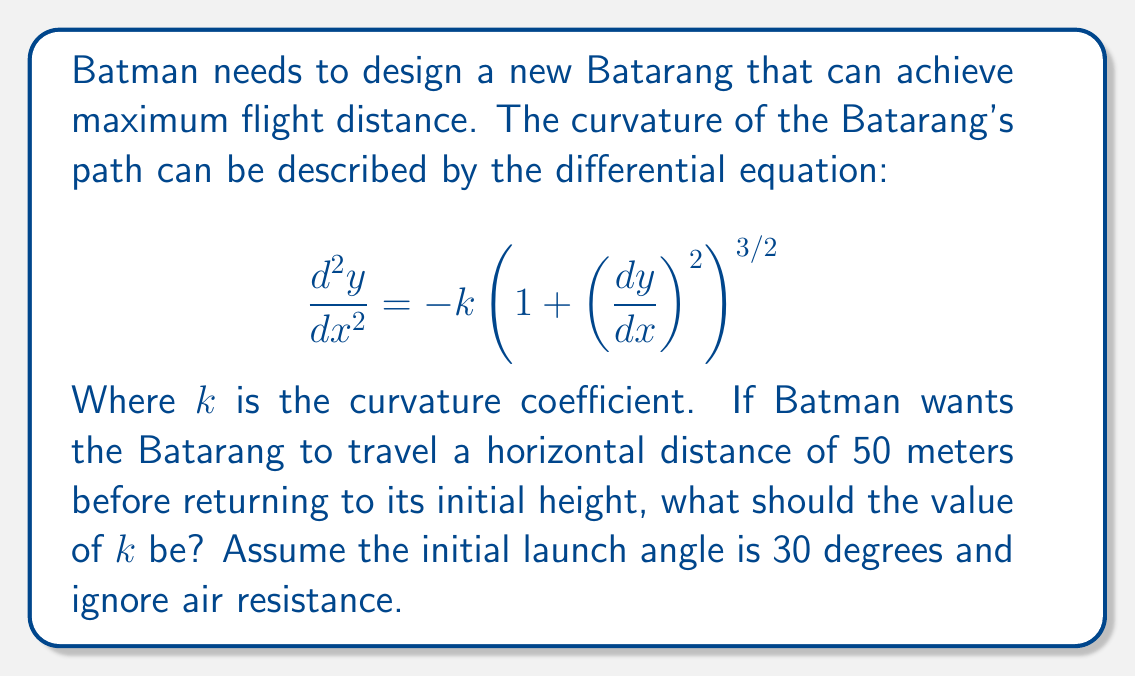Help me with this question. To solve this problem, we'll use the following steps:

1) First, we need to understand the given differential equation. This is the equation for the curvature of a path in 2D space.

2) We're given that the Batarang should return to its initial height after traveling 50 meters horizontally. This means that the path forms a symmetric arc.

3) For a symmetric arc, the maximum height occurs at the midpoint of the horizontal distance. At this point, the slope $\frac{dy}{dx} = 0$.

4) We can use the conservation of energy principle. The initial kinetic energy will be converted to potential energy at the highest point.

5) The initial velocity components are:
   $v_x = v \cos(30°)$
   $v_y = v \sin(30°)$

6) At the highest point:
   $v_x$ remains the same (ignoring air resistance)
   $v_y = 0$

7) The change in height (h) can be found using:
   $\frac{1}{2}mv^2\sin^2(30°) = mgh$
   $h = \frac{v^2\sin^2(30°)}{2g}$

8) The time to reach the highest point is:
   $t = \frac{v\sin(30°)}{g}$

9) The horizontal distance to the highest point is:
   $25 = v\cos(30°) \cdot \frac{v\sin(30°)}{g}$

10) From this, we can find $v$:
    $v^2 = \frac{50g}{\sin(60°)}$

11) Now, we can find $h$:
    $h = \frac{50g}{2\sin(60°)} \cdot \frac{1}{4} = \frac{25g}{4\sin(60°)}$

12) The arc of the Batarang forms approximately a circular segment. For a circular segment:
    $k = \frac{1}{R} = \frac{8h}{4h^2 + L^2}$

Where $L$ is the chord length (50 in this case) and $h$ is the height we calculated.

13) Substituting our values:
    $k = \frac{8 \cdot \frac{25g}{4\sin(60°)}}{4(\frac{25g}{4\sin(60°)})^2 + 50^2}$

14) Simplifying:
    $k = \frac{50g}{25g^2/(4\sin^2(60°)) + 625}$

15) Given $g \approx 9.8 m/s^2$, we can calculate the final value of $k$.
Answer: $k \approx 0.0308 m^{-1}$ 